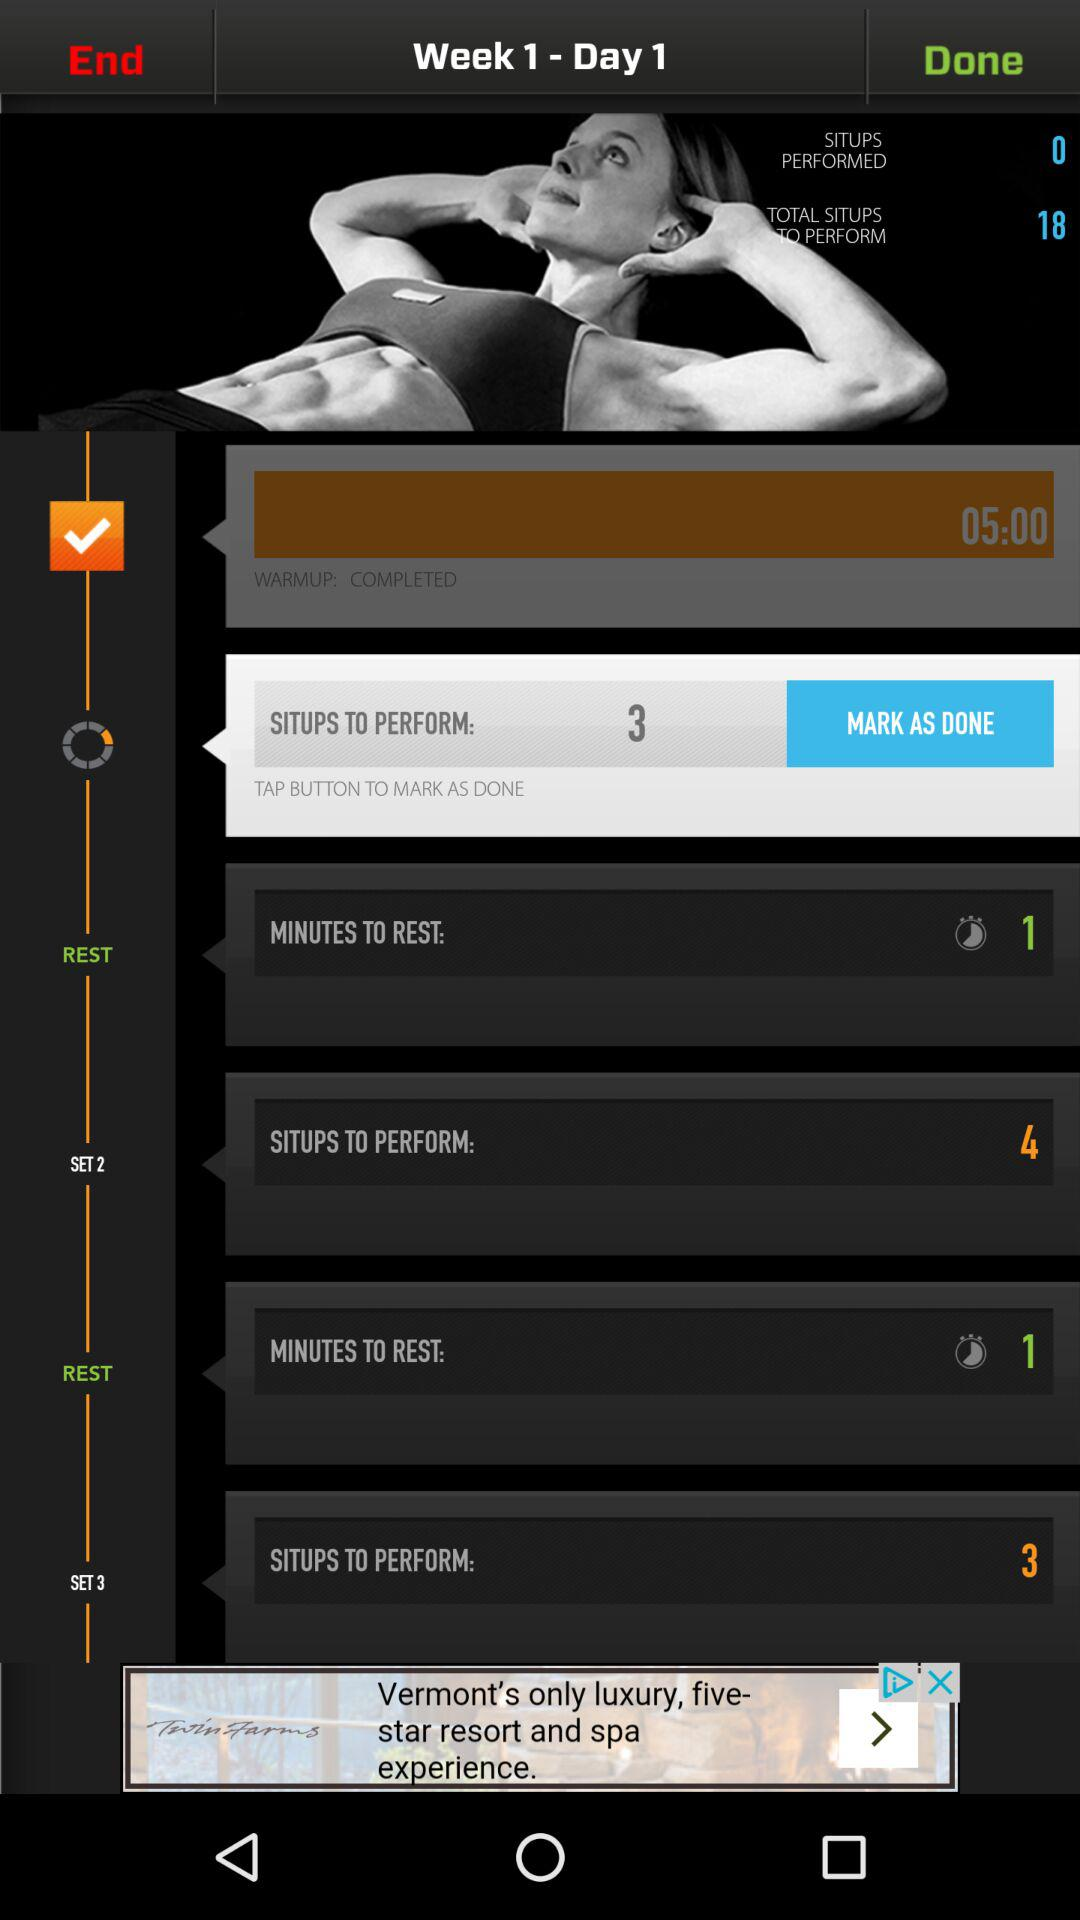What is the mentioned week and day? The mentioned week and day are "Week 1" and "Day 1", respectively. 